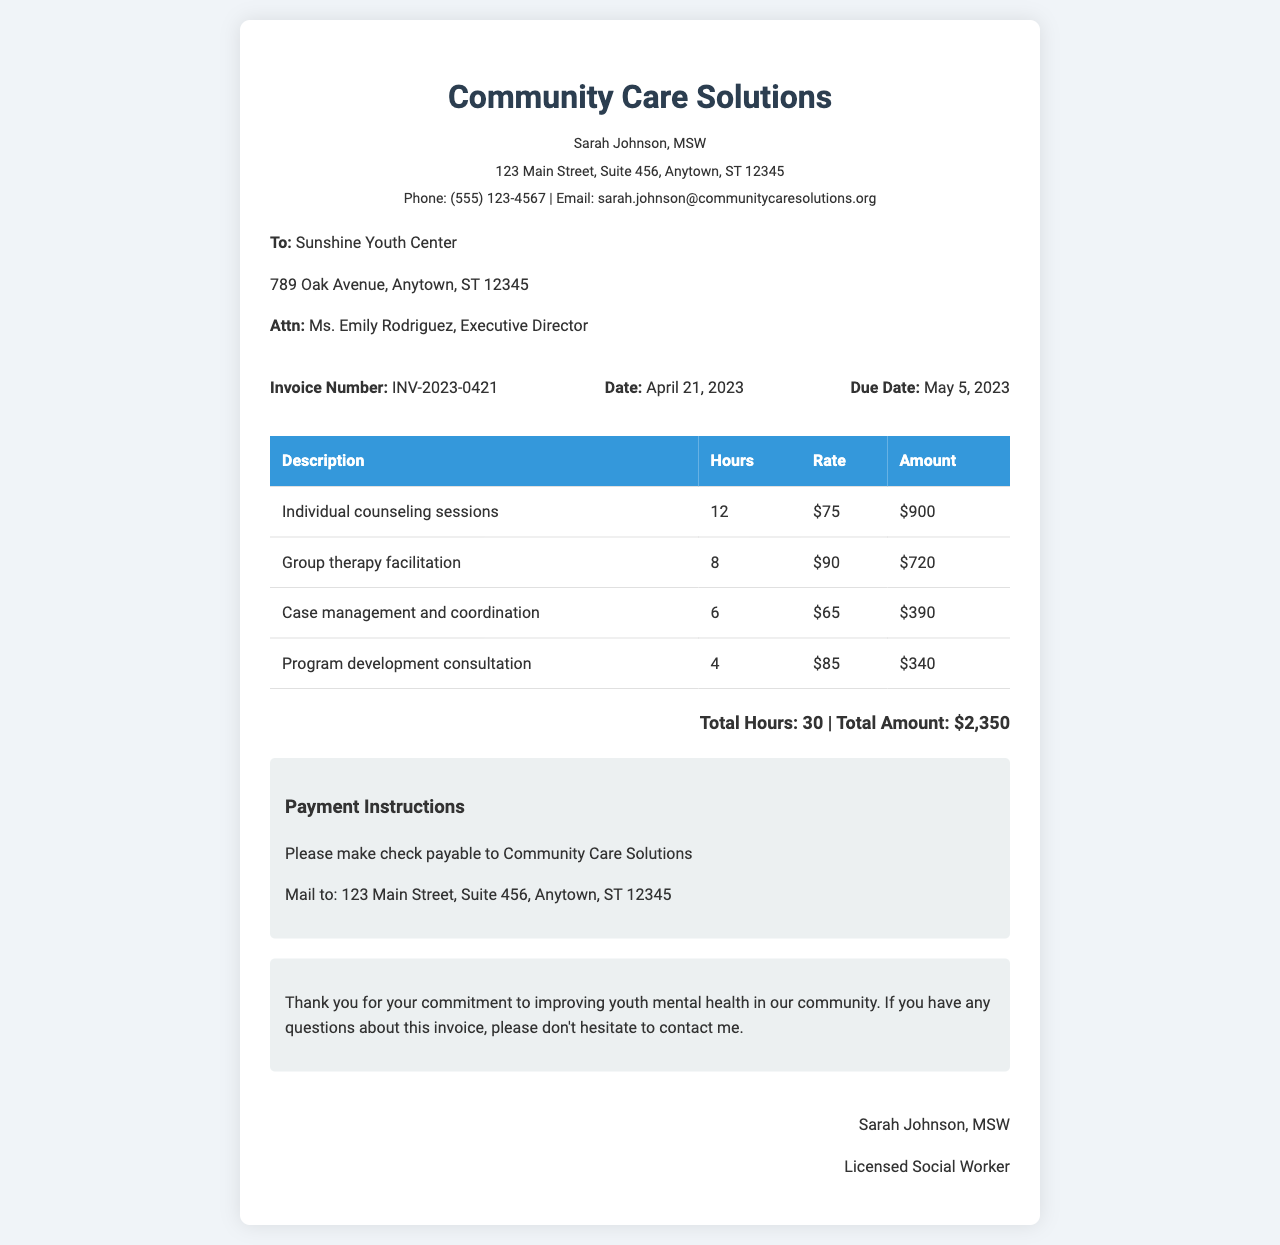What is the name of the service provider? The service provider's name is listed at the top of the document as Community Care Solutions.
Answer: Community Care Solutions What is the total amount invoiced? The total amount is provided in the total section of the invoice, summing all the activities listed.
Answer: $2,350 Who is the recipient of the invoice? The document specifies Sunshine Youth Center as the recipient in the recipient section.
Answer: Sunshine Youth Center How many hours were spent on individual counseling sessions? The hours for individual counseling are explicitly stated in the activity table.
Answer: 12 What is the due date for the invoice? The due date is clearly mentioned in the invoice details section.
Answer: May 5, 2023 What is the rate for group therapy facilitation? The rate for group therapy facilitation is provided in the table of activities under the corresponding rate column.
Answer: $90 What is the total number of hours worked? The total hours worked are detailed in the total section of the invoice, which adds up all the hours across activities.
Answer: 30 What is the address of the service provider? The address is presented in the header section of the document.
Answer: 123 Main Street, Suite 456, Anytown, ST 12345 What payment method is preferred? The payment instructions section states the preferred payment method for the invoice.
Answer: Check 